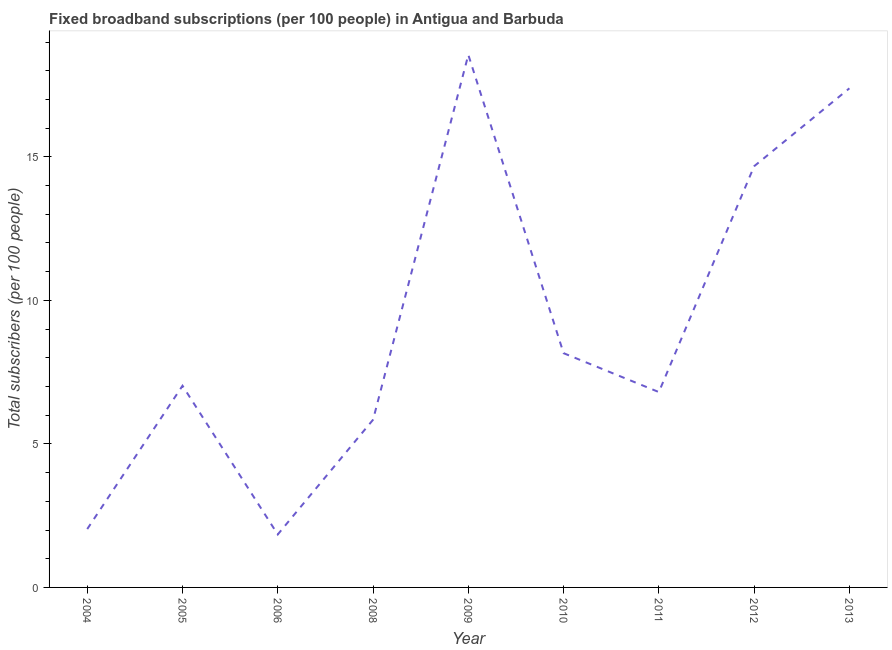What is the total number of fixed broadband subscriptions in 2011?
Your answer should be compact. 6.81. Across all years, what is the maximum total number of fixed broadband subscriptions?
Provide a succinct answer. 18.56. Across all years, what is the minimum total number of fixed broadband subscriptions?
Give a very brief answer. 1.85. In which year was the total number of fixed broadband subscriptions maximum?
Provide a short and direct response. 2009. What is the sum of the total number of fixed broadband subscriptions?
Your response must be concise. 82.33. What is the difference between the total number of fixed broadband subscriptions in 2009 and 2013?
Provide a succinct answer. 1.17. What is the average total number of fixed broadband subscriptions per year?
Provide a short and direct response. 9.15. What is the median total number of fixed broadband subscriptions?
Keep it short and to the point. 7.03. What is the ratio of the total number of fixed broadband subscriptions in 2006 to that in 2008?
Provide a succinct answer. 0.32. Is the total number of fixed broadband subscriptions in 2011 less than that in 2013?
Keep it short and to the point. Yes. What is the difference between the highest and the second highest total number of fixed broadband subscriptions?
Keep it short and to the point. 1.17. What is the difference between the highest and the lowest total number of fixed broadband subscriptions?
Give a very brief answer. 16.71. Does the total number of fixed broadband subscriptions monotonically increase over the years?
Ensure brevity in your answer.  No. How many lines are there?
Make the answer very short. 1. Does the graph contain grids?
Give a very brief answer. No. What is the title of the graph?
Give a very brief answer. Fixed broadband subscriptions (per 100 people) in Antigua and Barbuda. What is the label or title of the Y-axis?
Your response must be concise. Total subscribers (per 100 people). What is the Total subscribers (per 100 people) of 2004?
Your answer should be compact. 2.03. What is the Total subscribers (per 100 people) in 2005?
Give a very brief answer. 7.03. What is the Total subscribers (per 100 people) of 2006?
Make the answer very short. 1.85. What is the Total subscribers (per 100 people) in 2008?
Provide a short and direct response. 5.84. What is the Total subscribers (per 100 people) in 2009?
Make the answer very short. 18.56. What is the Total subscribers (per 100 people) of 2010?
Offer a terse response. 8.16. What is the Total subscribers (per 100 people) of 2011?
Provide a succinct answer. 6.81. What is the Total subscribers (per 100 people) of 2012?
Your response must be concise. 14.67. What is the Total subscribers (per 100 people) of 2013?
Offer a very short reply. 17.39. What is the difference between the Total subscribers (per 100 people) in 2004 and 2005?
Provide a short and direct response. -4.99. What is the difference between the Total subscribers (per 100 people) in 2004 and 2006?
Keep it short and to the point. 0.19. What is the difference between the Total subscribers (per 100 people) in 2004 and 2008?
Offer a very short reply. -3.81. What is the difference between the Total subscribers (per 100 people) in 2004 and 2009?
Your answer should be very brief. -16.52. What is the difference between the Total subscribers (per 100 people) in 2004 and 2010?
Give a very brief answer. -6.13. What is the difference between the Total subscribers (per 100 people) in 2004 and 2011?
Your answer should be very brief. -4.77. What is the difference between the Total subscribers (per 100 people) in 2004 and 2012?
Your answer should be compact. -12.64. What is the difference between the Total subscribers (per 100 people) in 2004 and 2013?
Your answer should be compact. -15.35. What is the difference between the Total subscribers (per 100 people) in 2005 and 2006?
Provide a short and direct response. 5.18. What is the difference between the Total subscribers (per 100 people) in 2005 and 2008?
Your response must be concise. 1.18. What is the difference between the Total subscribers (per 100 people) in 2005 and 2009?
Your answer should be compact. -11.53. What is the difference between the Total subscribers (per 100 people) in 2005 and 2010?
Provide a succinct answer. -1.13. What is the difference between the Total subscribers (per 100 people) in 2005 and 2011?
Ensure brevity in your answer.  0.22. What is the difference between the Total subscribers (per 100 people) in 2005 and 2012?
Give a very brief answer. -7.65. What is the difference between the Total subscribers (per 100 people) in 2005 and 2013?
Ensure brevity in your answer.  -10.36. What is the difference between the Total subscribers (per 100 people) in 2006 and 2008?
Your response must be concise. -4. What is the difference between the Total subscribers (per 100 people) in 2006 and 2009?
Keep it short and to the point. -16.71. What is the difference between the Total subscribers (per 100 people) in 2006 and 2010?
Your response must be concise. -6.31. What is the difference between the Total subscribers (per 100 people) in 2006 and 2011?
Make the answer very short. -4.96. What is the difference between the Total subscribers (per 100 people) in 2006 and 2012?
Your answer should be compact. -12.83. What is the difference between the Total subscribers (per 100 people) in 2006 and 2013?
Your answer should be very brief. -15.54. What is the difference between the Total subscribers (per 100 people) in 2008 and 2009?
Your response must be concise. -12.71. What is the difference between the Total subscribers (per 100 people) in 2008 and 2010?
Ensure brevity in your answer.  -2.32. What is the difference between the Total subscribers (per 100 people) in 2008 and 2011?
Your response must be concise. -0.96. What is the difference between the Total subscribers (per 100 people) in 2008 and 2012?
Provide a short and direct response. -8.83. What is the difference between the Total subscribers (per 100 people) in 2008 and 2013?
Your answer should be very brief. -11.55. What is the difference between the Total subscribers (per 100 people) in 2009 and 2010?
Provide a short and direct response. 10.4. What is the difference between the Total subscribers (per 100 people) in 2009 and 2011?
Offer a very short reply. 11.75. What is the difference between the Total subscribers (per 100 people) in 2009 and 2012?
Keep it short and to the point. 3.88. What is the difference between the Total subscribers (per 100 people) in 2009 and 2013?
Ensure brevity in your answer.  1.17. What is the difference between the Total subscribers (per 100 people) in 2010 and 2011?
Offer a very short reply. 1.35. What is the difference between the Total subscribers (per 100 people) in 2010 and 2012?
Keep it short and to the point. -6.51. What is the difference between the Total subscribers (per 100 people) in 2010 and 2013?
Give a very brief answer. -9.23. What is the difference between the Total subscribers (per 100 people) in 2011 and 2012?
Your answer should be very brief. -7.87. What is the difference between the Total subscribers (per 100 people) in 2011 and 2013?
Offer a very short reply. -10.58. What is the difference between the Total subscribers (per 100 people) in 2012 and 2013?
Offer a very short reply. -2.71. What is the ratio of the Total subscribers (per 100 people) in 2004 to that in 2005?
Your answer should be very brief. 0.29. What is the ratio of the Total subscribers (per 100 people) in 2004 to that in 2006?
Make the answer very short. 1.1. What is the ratio of the Total subscribers (per 100 people) in 2004 to that in 2008?
Provide a short and direct response. 0.35. What is the ratio of the Total subscribers (per 100 people) in 2004 to that in 2009?
Offer a terse response. 0.11. What is the ratio of the Total subscribers (per 100 people) in 2004 to that in 2010?
Your response must be concise. 0.25. What is the ratio of the Total subscribers (per 100 people) in 2004 to that in 2011?
Provide a short and direct response. 0.3. What is the ratio of the Total subscribers (per 100 people) in 2004 to that in 2012?
Offer a very short reply. 0.14. What is the ratio of the Total subscribers (per 100 people) in 2004 to that in 2013?
Provide a short and direct response. 0.12. What is the ratio of the Total subscribers (per 100 people) in 2005 to that in 2006?
Provide a short and direct response. 3.81. What is the ratio of the Total subscribers (per 100 people) in 2005 to that in 2008?
Ensure brevity in your answer.  1.2. What is the ratio of the Total subscribers (per 100 people) in 2005 to that in 2009?
Your answer should be compact. 0.38. What is the ratio of the Total subscribers (per 100 people) in 2005 to that in 2010?
Offer a very short reply. 0.86. What is the ratio of the Total subscribers (per 100 people) in 2005 to that in 2011?
Your answer should be compact. 1.03. What is the ratio of the Total subscribers (per 100 people) in 2005 to that in 2012?
Offer a terse response. 0.48. What is the ratio of the Total subscribers (per 100 people) in 2005 to that in 2013?
Provide a succinct answer. 0.4. What is the ratio of the Total subscribers (per 100 people) in 2006 to that in 2008?
Provide a short and direct response. 0.32. What is the ratio of the Total subscribers (per 100 people) in 2006 to that in 2009?
Make the answer very short. 0.1. What is the ratio of the Total subscribers (per 100 people) in 2006 to that in 2010?
Give a very brief answer. 0.23. What is the ratio of the Total subscribers (per 100 people) in 2006 to that in 2011?
Give a very brief answer. 0.27. What is the ratio of the Total subscribers (per 100 people) in 2006 to that in 2012?
Your response must be concise. 0.13. What is the ratio of the Total subscribers (per 100 people) in 2006 to that in 2013?
Keep it short and to the point. 0.11. What is the ratio of the Total subscribers (per 100 people) in 2008 to that in 2009?
Provide a short and direct response. 0.32. What is the ratio of the Total subscribers (per 100 people) in 2008 to that in 2010?
Offer a very short reply. 0.72. What is the ratio of the Total subscribers (per 100 people) in 2008 to that in 2011?
Provide a succinct answer. 0.86. What is the ratio of the Total subscribers (per 100 people) in 2008 to that in 2012?
Make the answer very short. 0.4. What is the ratio of the Total subscribers (per 100 people) in 2008 to that in 2013?
Keep it short and to the point. 0.34. What is the ratio of the Total subscribers (per 100 people) in 2009 to that in 2010?
Offer a very short reply. 2.27. What is the ratio of the Total subscribers (per 100 people) in 2009 to that in 2011?
Give a very brief answer. 2.73. What is the ratio of the Total subscribers (per 100 people) in 2009 to that in 2012?
Offer a very short reply. 1.26. What is the ratio of the Total subscribers (per 100 people) in 2009 to that in 2013?
Offer a terse response. 1.07. What is the ratio of the Total subscribers (per 100 people) in 2010 to that in 2011?
Provide a short and direct response. 1.2. What is the ratio of the Total subscribers (per 100 people) in 2010 to that in 2012?
Your answer should be very brief. 0.56. What is the ratio of the Total subscribers (per 100 people) in 2010 to that in 2013?
Offer a terse response. 0.47. What is the ratio of the Total subscribers (per 100 people) in 2011 to that in 2012?
Make the answer very short. 0.46. What is the ratio of the Total subscribers (per 100 people) in 2011 to that in 2013?
Offer a terse response. 0.39. What is the ratio of the Total subscribers (per 100 people) in 2012 to that in 2013?
Your answer should be very brief. 0.84. 